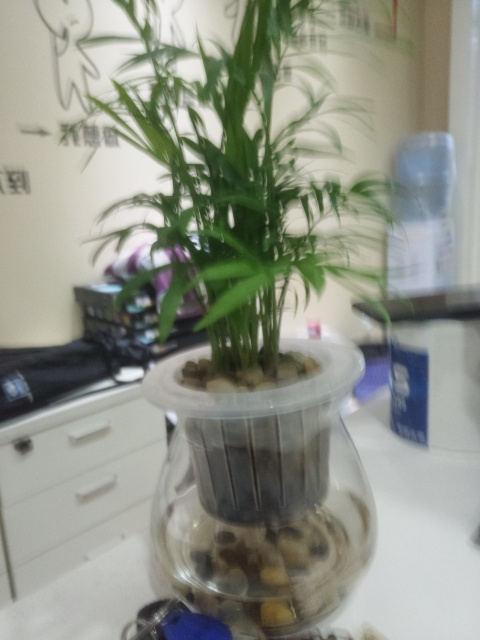Can you tell me more about the container the plant is in? The plant is situated in a clear glass container that functions as a planter. The bottom layer contains stones, which suggests it may also serve as a hydroponic system, where plants are grown in water without soil, relying on the stones for support. 